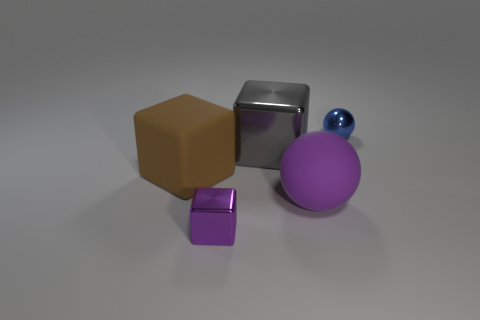Is the color of the small metal cube the same as the matte sphere?
Keep it short and to the point. Yes. What number of blue metallic balls are on the right side of the large rubber object on the left side of the sphere that is in front of the large brown block?
Make the answer very short. 1. The small thing behind the block to the left of the tiny shiny object that is in front of the blue metal object is made of what material?
Offer a terse response. Metal. Are the tiny object that is behind the large brown rubber block and the purple block made of the same material?
Offer a very short reply. Yes. How many purple things have the same size as the shiny ball?
Provide a succinct answer. 1. Is the number of big things that are right of the purple cube greater than the number of gray objects that are on the right side of the big purple matte thing?
Make the answer very short. Yes. Is there a small blue shiny thing of the same shape as the big purple matte thing?
Keep it short and to the point. Yes. There is a shiny cube in front of the rubber thing that is on the left side of the big gray block; what size is it?
Your response must be concise. Small. The tiny metallic object that is on the left side of the tiny shiny object on the right side of the tiny metal object in front of the big purple ball is what shape?
Your response must be concise. Cube. There is a purple thing that is made of the same material as the small blue ball; what size is it?
Make the answer very short. Small. 